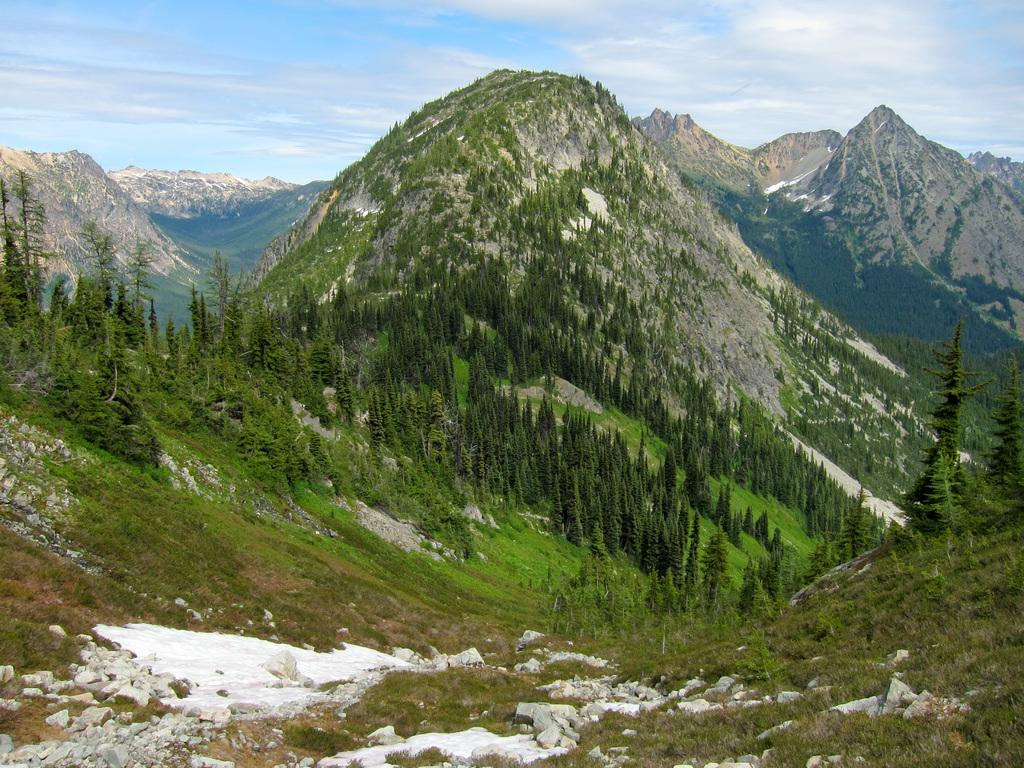What type of landscape can be seen in the background of the image? There are hills in the background of the image. What can be found on the hills? Trees and plants are present on the hills. What is the condition of the land in the front of the image? There is snow on the land in the front of the image. What is visible in the sky in the image? The sky is visible in the image, and clouds are present. What scientific theory is being tested in the image? There is no indication of a scientific theory being tested in the image. Is there a volcano visible in the image? No, there is no volcano present in the image. 